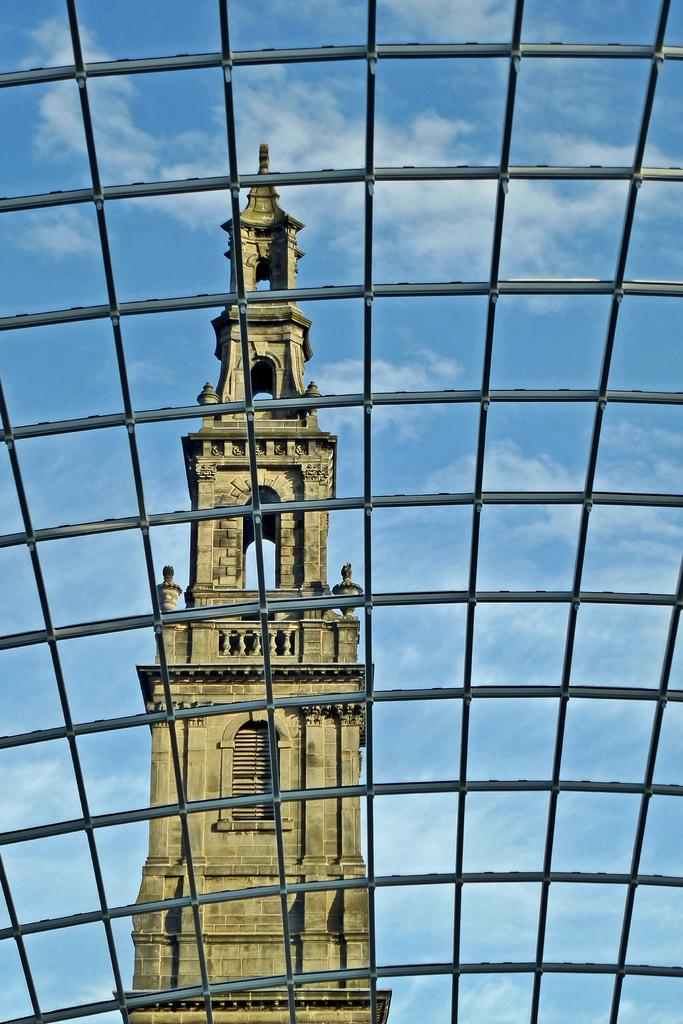What can be seen in the foreground of the image? There are grills in the foreground of the image. What is visible in the background of the image? There is a building and the sky in the background of the image. How many oranges are being cooked on the grills in the image? There are no oranges present in the image, and the grills are not being used for cooking. What type of railway can be seen in the image? There is no railway present in the image. 